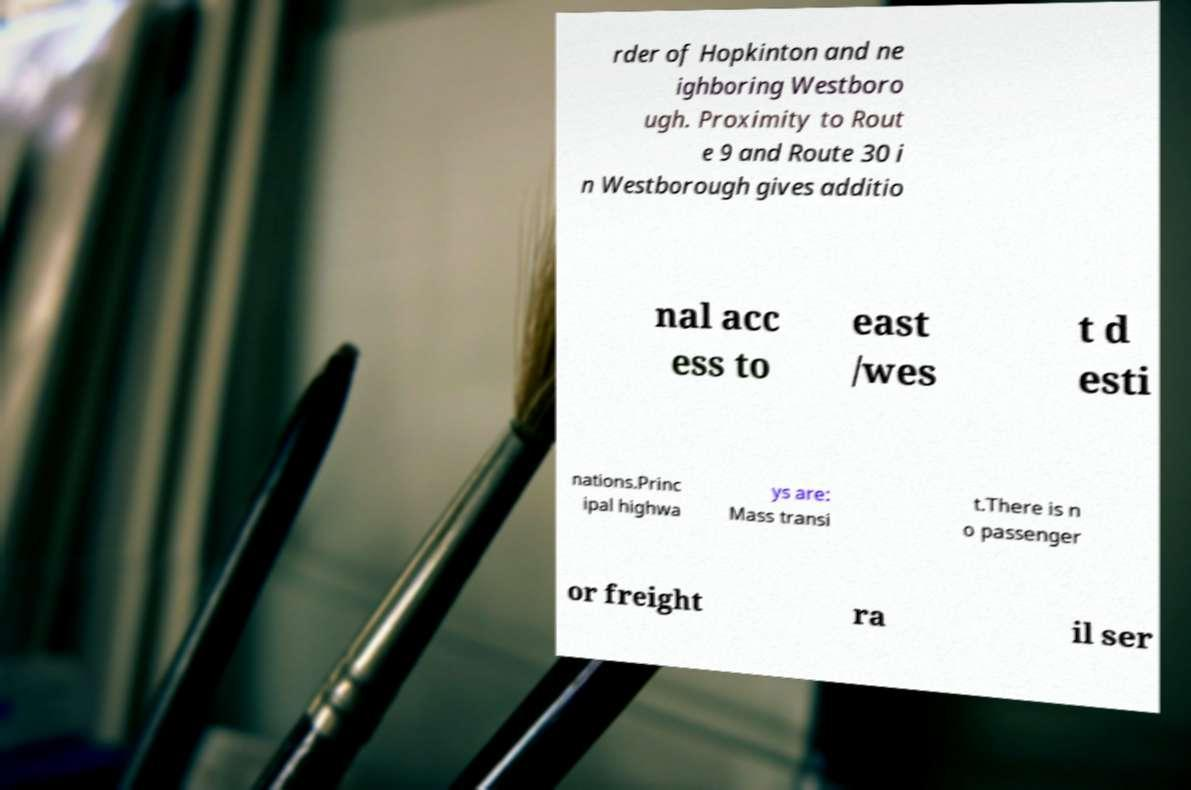I need the written content from this picture converted into text. Can you do that? rder of Hopkinton and ne ighboring Westboro ugh. Proximity to Rout e 9 and Route 30 i n Westborough gives additio nal acc ess to east /wes t d esti nations.Princ ipal highwa ys are: Mass transi t.There is n o passenger or freight ra il ser 